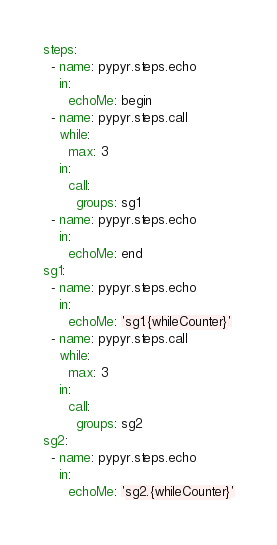<code> <loc_0><loc_0><loc_500><loc_500><_YAML_>steps:
  - name: pypyr.steps.echo
    in:
      echoMe: begin
  - name: pypyr.steps.call
    while:
      max: 3
    in:
      call:
        groups: sg1
  - name: pypyr.steps.echo
    in:
      echoMe: end
sg1:
  - name: pypyr.steps.echo
    in:
      echoMe: 'sg1.{whileCounter}'
  - name: pypyr.steps.call
    while:
      max: 3
    in:
      call:
        groups: sg2
sg2:
  - name: pypyr.steps.echo
    in:
      echoMe: 'sg2.{whileCounter}'
</code> 